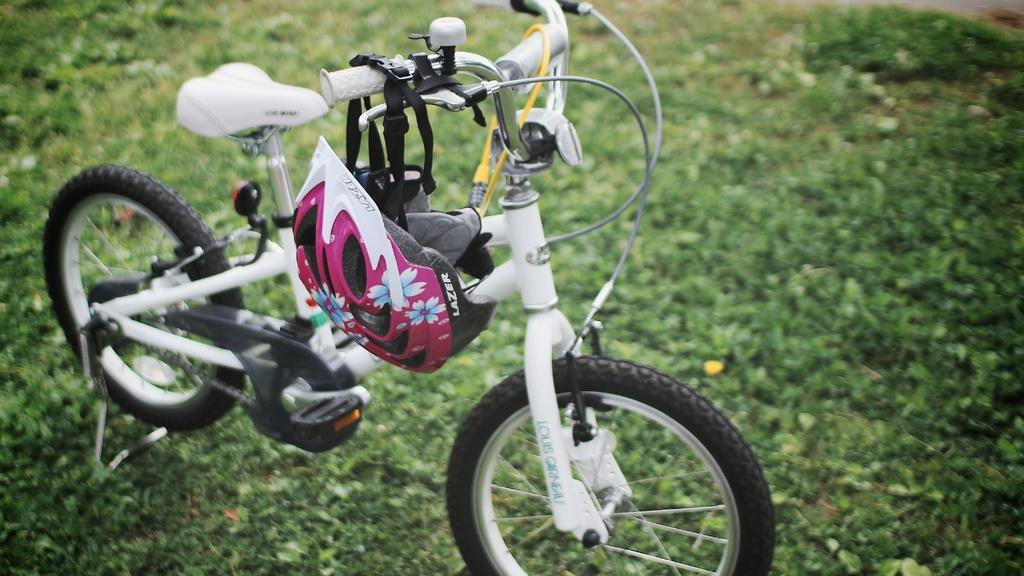What is the main object in the image? There is a bicycle in the image. What is the color of the bicycle? The bicycle is off-white in color. What safety equipment is present in the image? There is a helmet in the image. What type of terrain is visible at the bottom of the image? Grass is visible at the bottom of the image. How many snowflakes are falling in the image? There are no snowflakes visible in the image, as it features a bicycle, helmet, and grass. What type of cough medicine is present in the image? There is no cough medicine present in the image; it features a bicycle, helmet, and grass. 